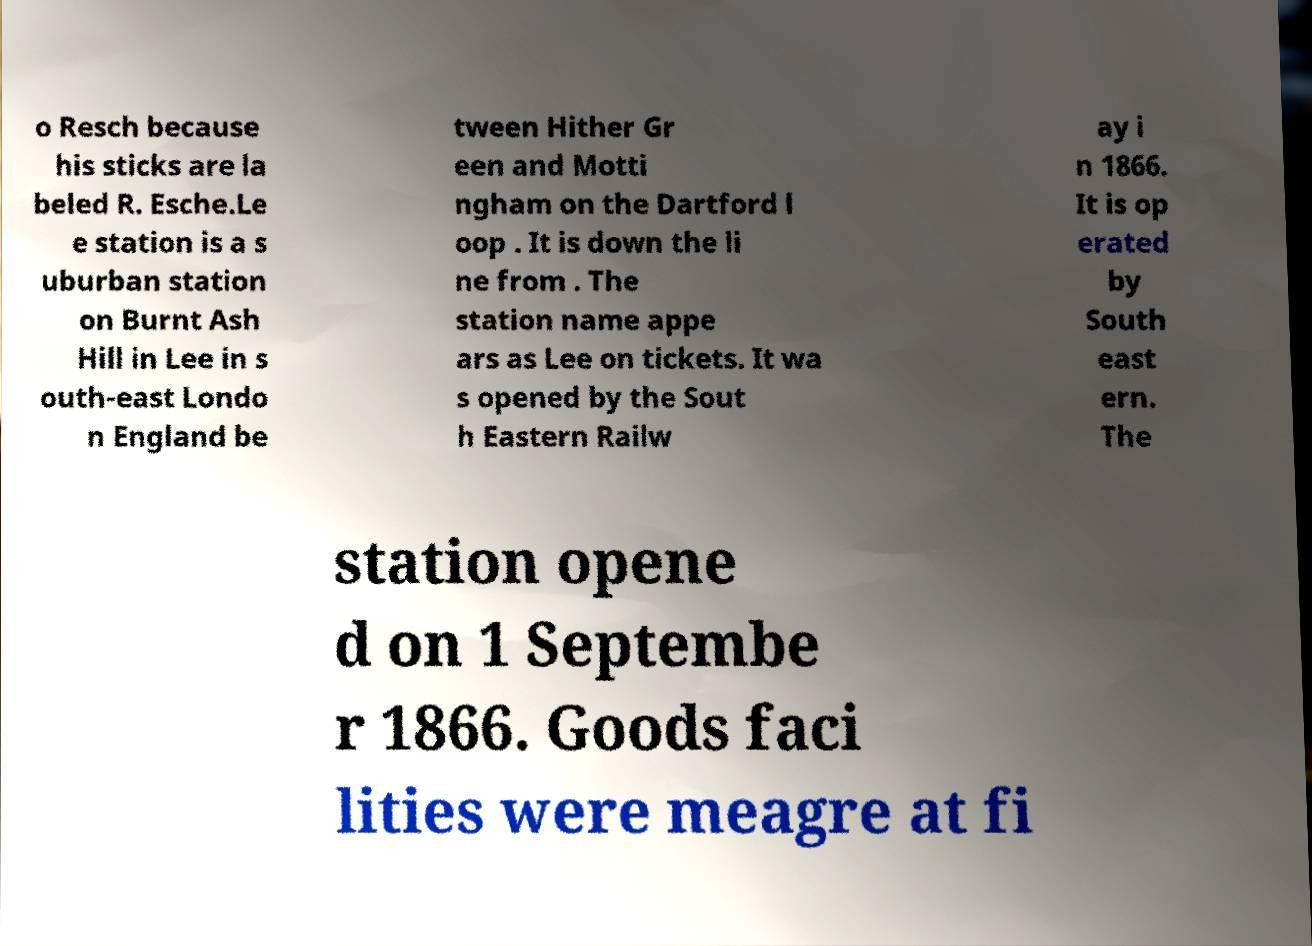Can you read and provide the text displayed in the image?This photo seems to have some interesting text. Can you extract and type it out for me? o Resch because his sticks are la beled R. Esche.Le e station is a s uburban station on Burnt Ash Hill in Lee in s outh-east Londo n England be tween Hither Gr een and Motti ngham on the Dartford l oop . It is down the li ne from . The station name appe ars as Lee on tickets. It wa s opened by the Sout h Eastern Railw ay i n 1866. It is op erated by South east ern. The station opene d on 1 Septembe r 1866. Goods faci lities were meagre at fi 